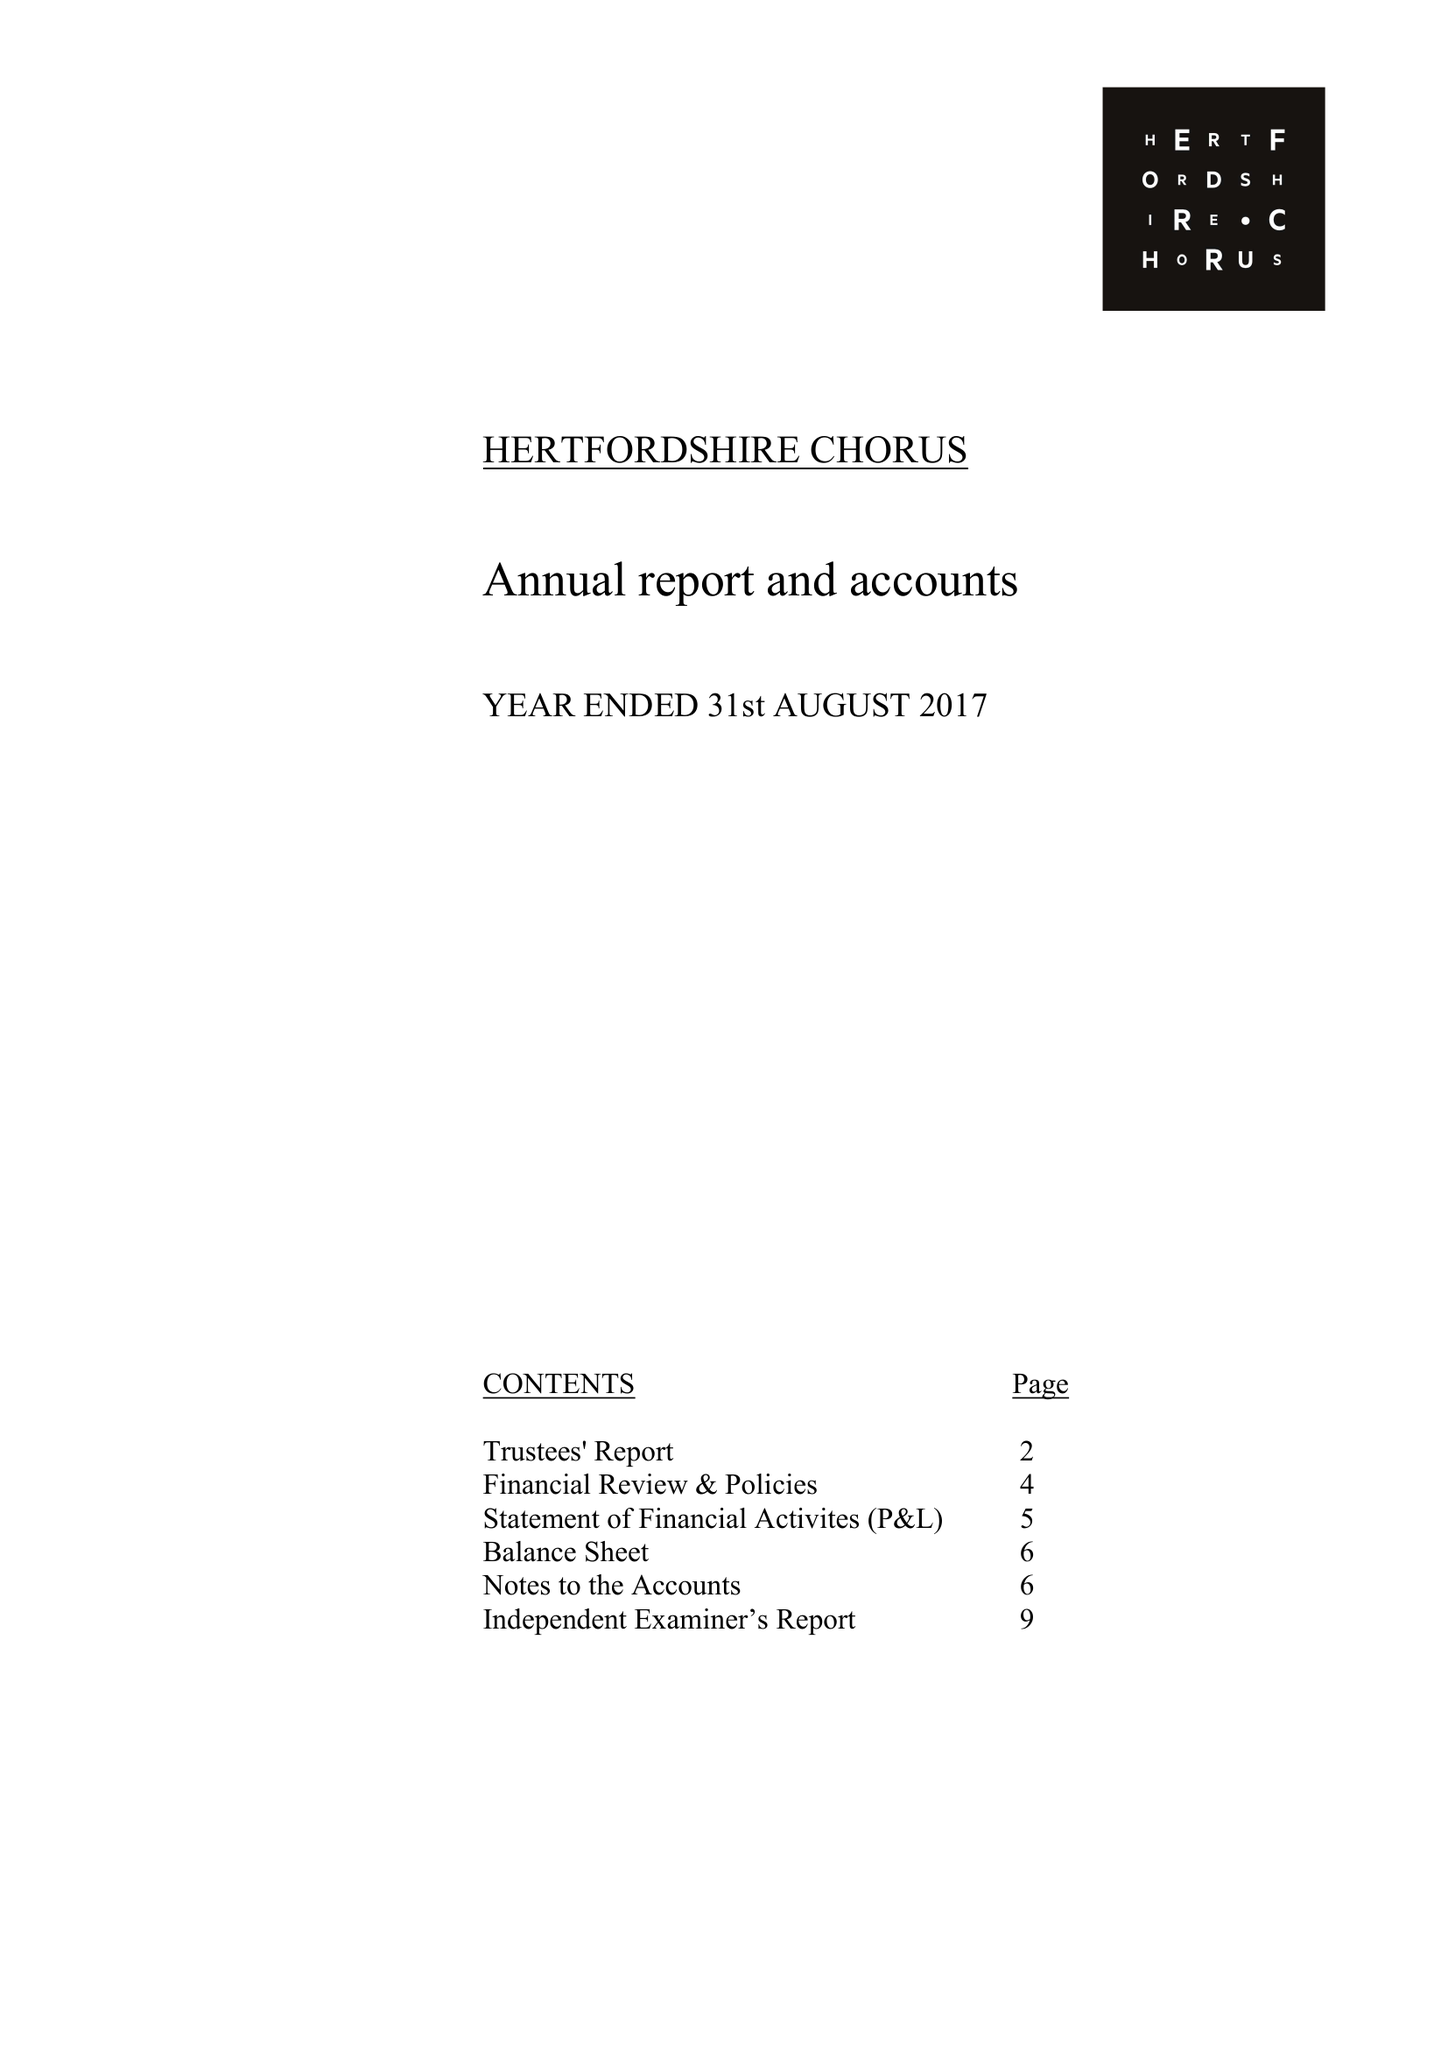What is the value for the address__street_line?
Answer the question using a single word or phrase. 16 BARNCROFT WAY 